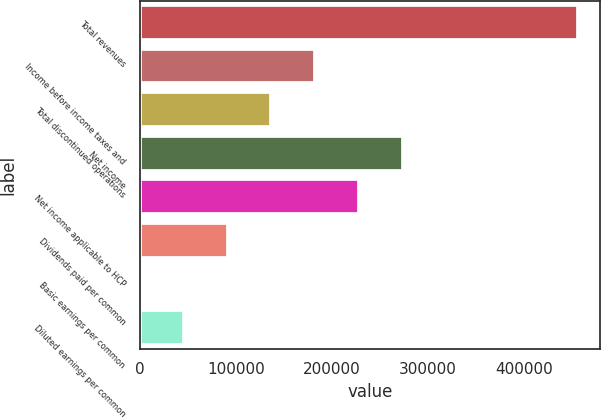Convert chart. <chart><loc_0><loc_0><loc_500><loc_500><bar_chart><fcel>Total revenues<fcel>Income before income taxes and<fcel>Total discontinued operations<fcel>Net income<fcel>Net income applicable to HCP<fcel>Dividends paid per common<fcel>Basic earnings per common<fcel>Diluted earnings per common<nl><fcel>455827<fcel>182331<fcel>136748<fcel>273496<fcel>227914<fcel>91165.8<fcel>0.43<fcel>45583.1<nl></chart> 